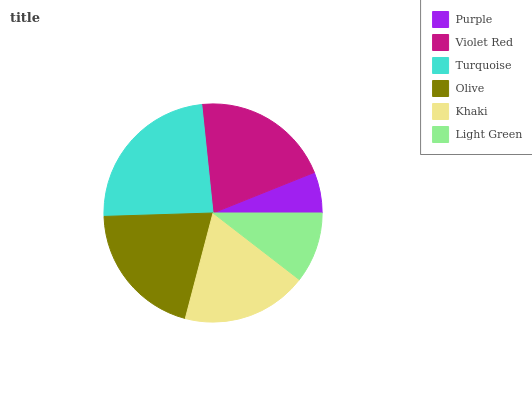Is Purple the minimum?
Answer yes or no. Yes. Is Turquoise the maximum?
Answer yes or no. Yes. Is Violet Red the minimum?
Answer yes or no. No. Is Violet Red the maximum?
Answer yes or no. No. Is Violet Red greater than Purple?
Answer yes or no. Yes. Is Purple less than Violet Red?
Answer yes or no. Yes. Is Purple greater than Violet Red?
Answer yes or no. No. Is Violet Red less than Purple?
Answer yes or no. No. Is Olive the high median?
Answer yes or no. Yes. Is Khaki the low median?
Answer yes or no. Yes. Is Violet Red the high median?
Answer yes or no. No. Is Light Green the low median?
Answer yes or no. No. 